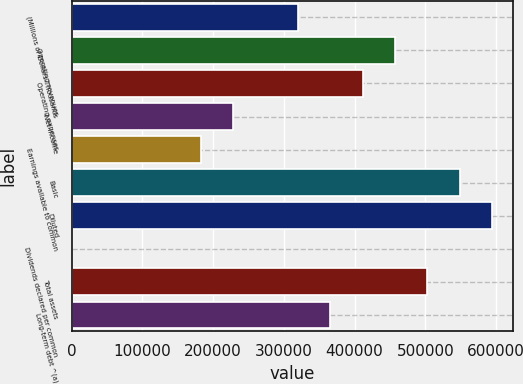<chart> <loc_0><loc_0><loc_500><loc_500><bar_chart><fcel>(Millions of Dollars Thousands<fcel>Operating revenues<fcel>Operating expenses<fcel>Net income<fcel>Earnings available to common<fcel>Basic<fcel>Diluted<fcel>Dividends declared per common<fcel>Total assets<fcel>Long-term debt ^(a)<nl><fcel>319998<fcel>457139<fcel>411425<fcel>228570<fcel>182856<fcel>548567<fcel>594280<fcel>0.97<fcel>502853<fcel>365711<nl></chart> 